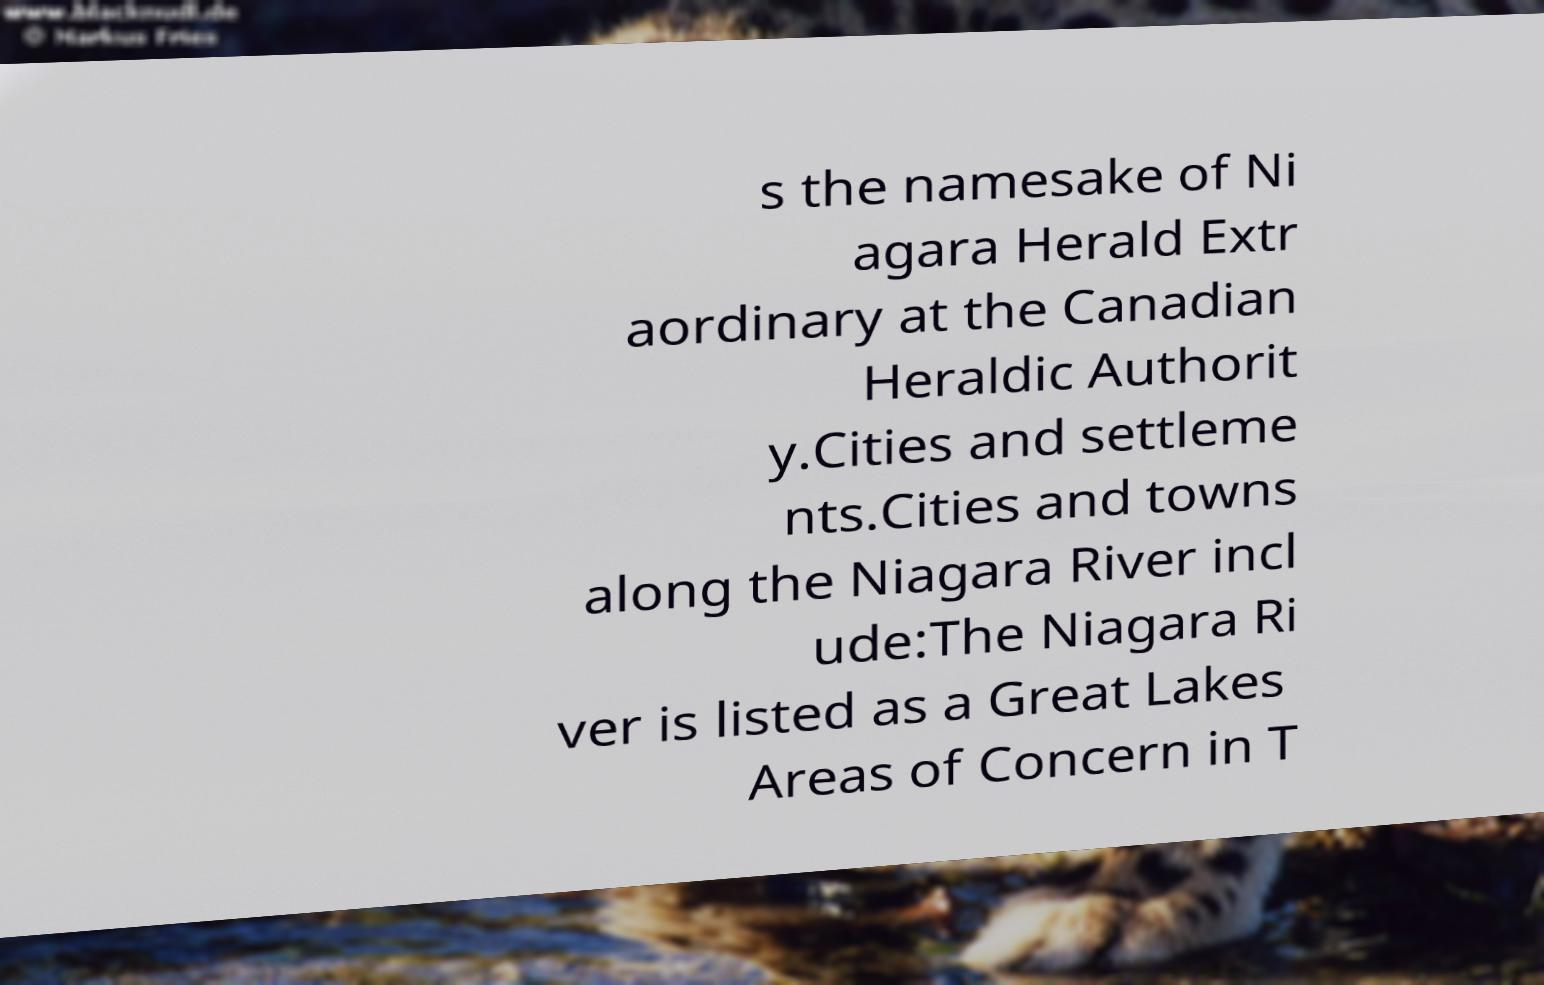Could you extract and type out the text from this image? s the namesake of Ni agara Herald Extr aordinary at the Canadian Heraldic Authorit y.Cities and settleme nts.Cities and towns along the Niagara River incl ude:The Niagara Ri ver is listed as a Great Lakes Areas of Concern in T 